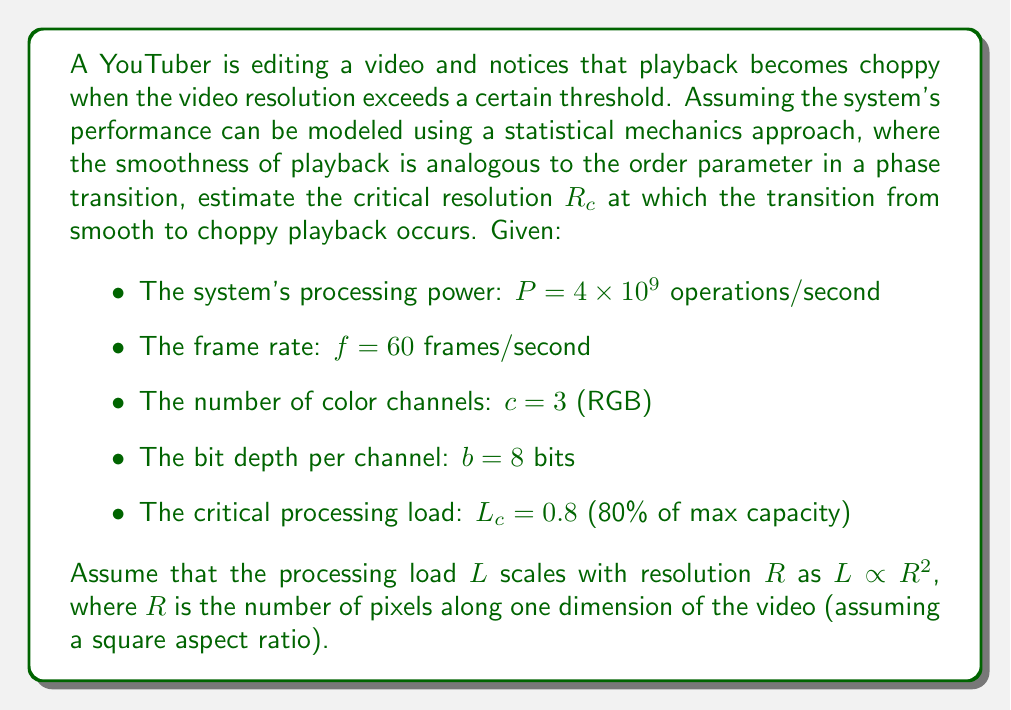Could you help me with this problem? To solve this problem, we'll follow these steps:

1) First, we need to express the processing load $L$ in terms of the resolution $R$. The total number of pixels in a frame is $R^2$, and each pixel has $c$ channels with $b$ bits each. The processing load per frame is proportional to $R^2 \cdot c \cdot b$.

2) The processing load per second is this multiplied by the frame rate $f$:

   $L \propto R^2 \cdot c \cdot b \cdot f$

3) We can write this as an equation by introducing a constant of proportionality $k$:

   $L = k \cdot R^2 \cdot c \cdot b \cdot f$

4) At the critical point, $L = L_c$ and $R = R_c$. Substituting these in:

   $L_c = k \cdot R_c^2 \cdot c \cdot b \cdot f$

5) We also know that $L_c = 0.8P$, where $P$ is the total processing power. So:

   $0.8P = k \cdot R_c^2 \cdot c \cdot b \cdot f$

6) Solving for $R_c$:

   $$R_c = \sqrt{\frac{0.8P}{k \cdot c \cdot b \cdot f}}$$

7) We don't know $k$, but we can eliminate it by considering that at maximum capacity ($L = 1$), the system should be able to process a 4K video ($R = 3840$):

   $P = k \cdot 3840^2 \cdot c \cdot b \cdot f$

8) Dividing the equation in step 5 by this equation:

   $$\frac{0.8P}{P} = \frac{R_c^2}{3840^2}$$

9) Simplifying and solving for $R_c$:

   $$R_c = 3840 \sqrt{0.8} \approx 3433$$

10) Therefore, the critical resolution at which the transition from smooth to choppy playback occurs is approximately 3433 x 3433 pixels.
Answer: $R_c \approx 3433$ pixels 